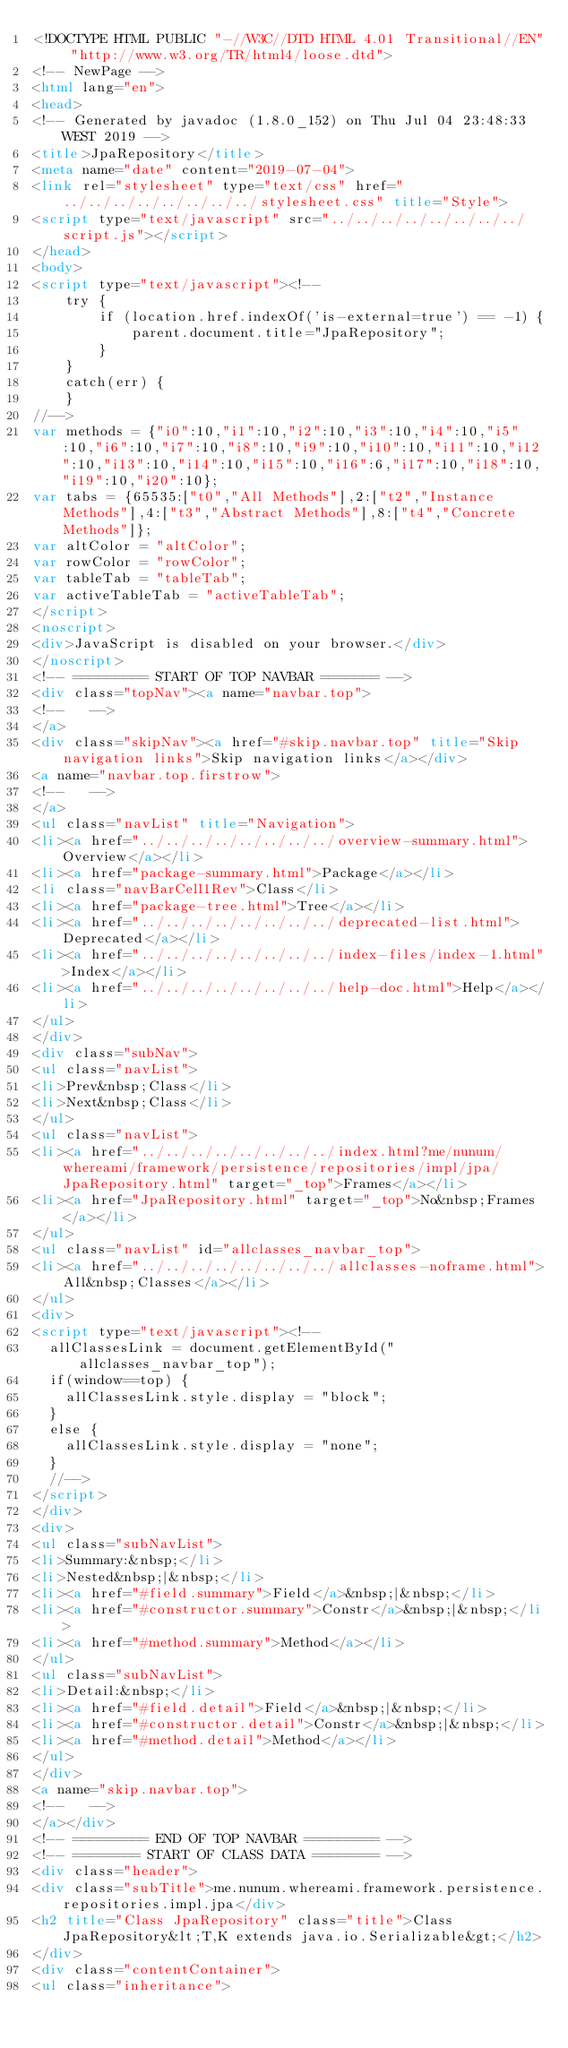Convert code to text. <code><loc_0><loc_0><loc_500><loc_500><_HTML_><!DOCTYPE HTML PUBLIC "-//W3C//DTD HTML 4.01 Transitional//EN" "http://www.w3.org/TR/html4/loose.dtd">
<!-- NewPage -->
<html lang="en">
<head>
<!-- Generated by javadoc (1.8.0_152) on Thu Jul 04 23:48:33 WEST 2019 -->
<title>JpaRepository</title>
<meta name="date" content="2019-07-04">
<link rel="stylesheet" type="text/css" href="../../../../../../../../stylesheet.css" title="Style">
<script type="text/javascript" src="../../../../../../../../script.js"></script>
</head>
<body>
<script type="text/javascript"><!--
    try {
        if (location.href.indexOf('is-external=true') == -1) {
            parent.document.title="JpaRepository";
        }
    }
    catch(err) {
    }
//-->
var methods = {"i0":10,"i1":10,"i2":10,"i3":10,"i4":10,"i5":10,"i6":10,"i7":10,"i8":10,"i9":10,"i10":10,"i11":10,"i12":10,"i13":10,"i14":10,"i15":10,"i16":6,"i17":10,"i18":10,"i19":10,"i20":10};
var tabs = {65535:["t0","All Methods"],2:["t2","Instance Methods"],4:["t3","Abstract Methods"],8:["t4","Concrete Methods"]};
var altColor = "altColor";
var rowColor = "rowColor";
var tableTab = "tableTab";
var activeTableTab = "activeTableTab";
</script>
<noscript>
<div>JavaScript is disabled on your browser.</div>
</noscript>
<!-- ========= START OF TOP NAVBAR ======= -->
<div class="topNav"><a name="navbar.top">
<!--   -->
</a>
<div class="skipNav"><a href="#skip.navbar.top" title="Skip navigation links">Skip navigation links</a></div>
<a name="navbar.top.firstrow">
<!--   -->
</a>
<ul class="navList" title="Navigation">
<li><a href="../../../../../../../../overview-summary.html">Overview</a></li>
<li><a href="package-summary.html">Package</a></li>
<li class="navBarCell1Rev">Class</li>
<li><a href="package-tree.html">Tree</a></li>
<li><a href="../../../../../../../../deprecated-list.html">Deprecated</a></li>
<li><a href="../../../../../../../../index-files/index-1.html">Index</a></li>
<li><a href="../../../../../../../../help-doc.html">Help</a></li>
</ul>
</div>
<div class="subNav">
<ul class="navList">
<li>Prev&nbsp;Class</li>
<li>Next&nbsp;Class</li>
</ul>
<ul class="navList">
<li><a href="../../../../../../../../index.html?me/nunum/whereami/framework/persistence/repositories/impl/jpa/JpaRepository.html" target="_top">Frames</a></li>
<li><a href="JpaRepository.html" target="_top">No&nbsp;Frames</a></li>
</ul>
<ul class="navList" id="allclasses_navbar_top">
<li><a href="../../../../../../../../allclasses-noframe.html">All&nbsp;Classes</a></li>
</ul>
<div>
<script type="text/javascript"><!--
  allClassesLink = document.getElementById("allclasses_navbar_top");
  if(window==top) {
    allClassesLink.style.display = "block";
  }
  else {
    allClassesLink.style.display = "none";
  }
  //-->
</script>
</div>
<div>
<ul class="subNavList">
<li>Summary:&nbsp;</li>
<li>Nested&nbsp;|&nbsp;</li>
<li><a href="#field.summary">Field</a>&nbsp;|&nbsp;</li>
<li><a href="#constructor.summary">Constr</a>&nbsp;|&nbsp;</li>
<li><a href="#method.summary">Method</a></li>
</ul>
<ul class="subNavList">
<li>Detail:&nbsp;</li>
<li><a href="#field.detail">Field</a>&nbsp;|&nbsp;</li>
<li><a href="#constructor.detail">Constr</a>&nbsp;|&nbsp;</li>
<li><a href="#method.detail">Method</a></li>
</ul>
</div>
<a name="skip.navbar.top">
<!--   -->
</a></div>
<!-- ========= END OF TOP NAVBAR ========= -->
<!-- ======== START OF CLASS DATA ======== -->
<div class="header">
<div class="subTitle">me.nunum.whereami.framework.persistence.repositories.impl.jpa</div>
<h2 title="Class JpaRepository" class="title">Class JpaRepository&lt;T,K extends java.io.Serializable&gt;</h2>
</div>
<div class="contentContainer">
<ul class="inheritance"></code> 